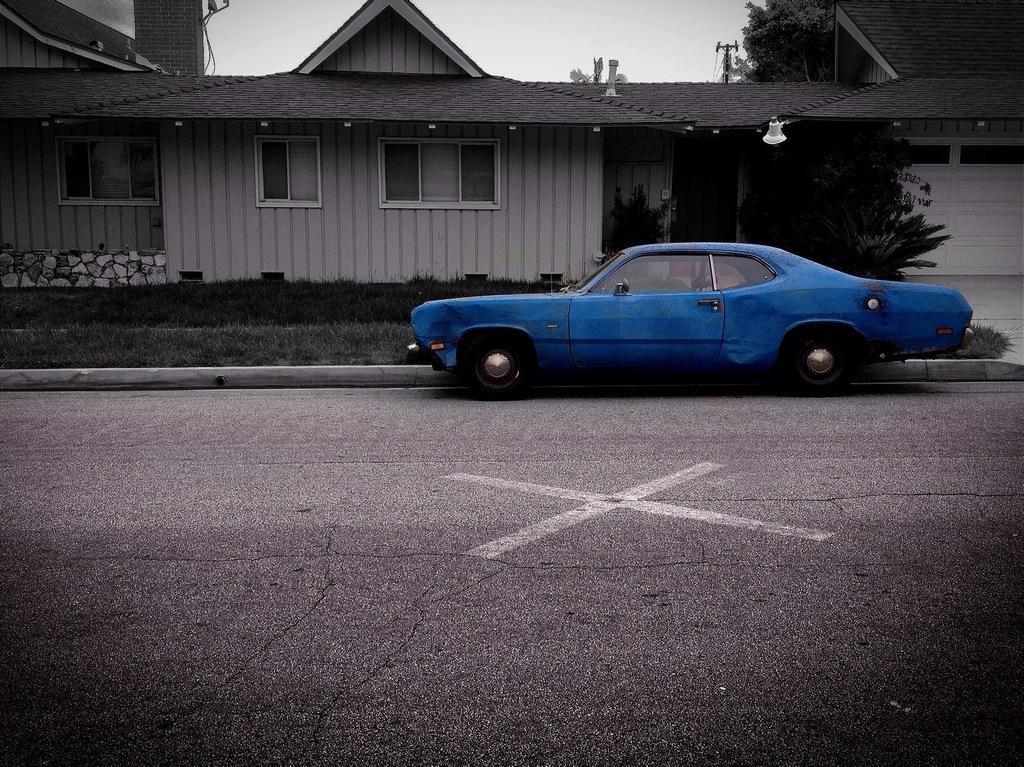Please provide a concise description of this image. In this image I can see the blue color vehicle on the road. To the side of the vehicle I can see the plants and the house with windows. In the background I can see the trees and the sky. 